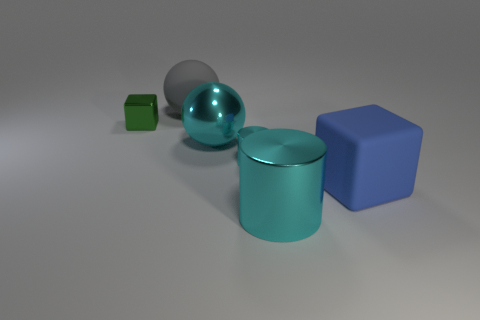Add 1 big blue cubes. How many objects exist? 7 Subtract all balls. How many objects are left? 4 Add 6 large matte blocks. How many large matte blocks exist? 7 Subtract 0 purple balls. How many objects are left? 6 Subtract all big blue rubber cubes. Subtract all big objects. How many objects are left? 1 Add 1 large gray matte spheres. How many large gray matte spheres are left? 2 